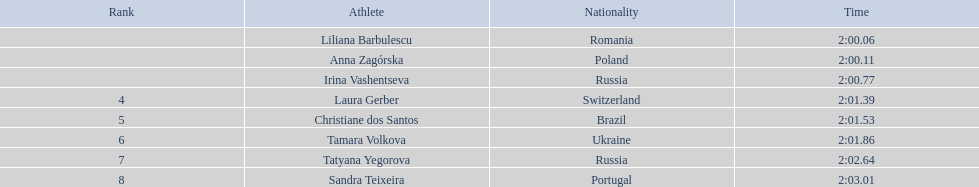Who came in second place at the athletics at the 2003 summer universiade - women's 800 metres? Anna Zagórska. What was her time? 2:00.11. 